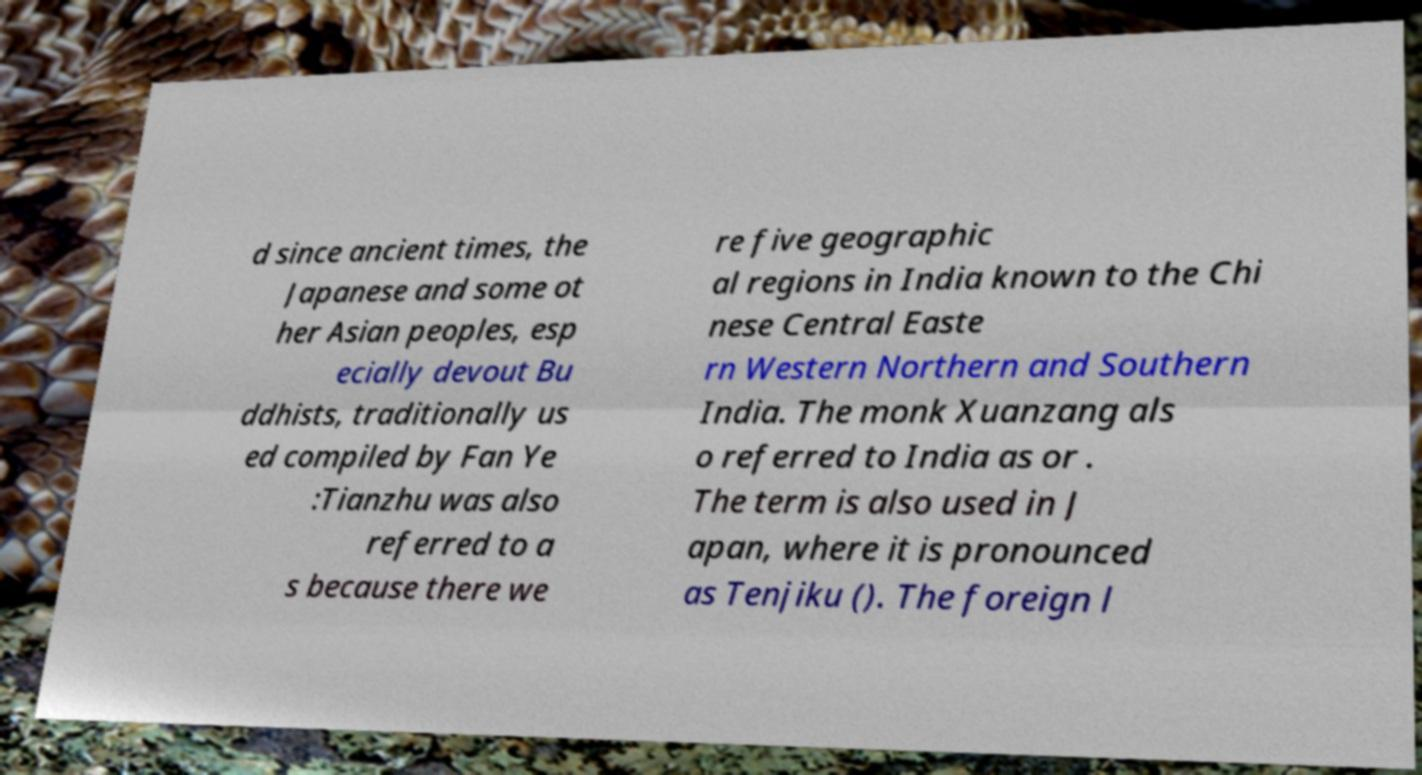I need the written content from this picture converted into text. Can you do that? d since ancient times, the Japanese and some ot her Asian peoples, esp ecially devout Bu ddhists, traditionally us ed compiled by Fan Ye :Tianzhu was also referred to a s because there we re five geographic al regions in India known to the Chi nese Central Easte rn Western Northern and Southern India. The monk Xuanzang als o referred to India as or . The term is also used in J apan, where it is pronounced as Tenjiku (). The foreign l 